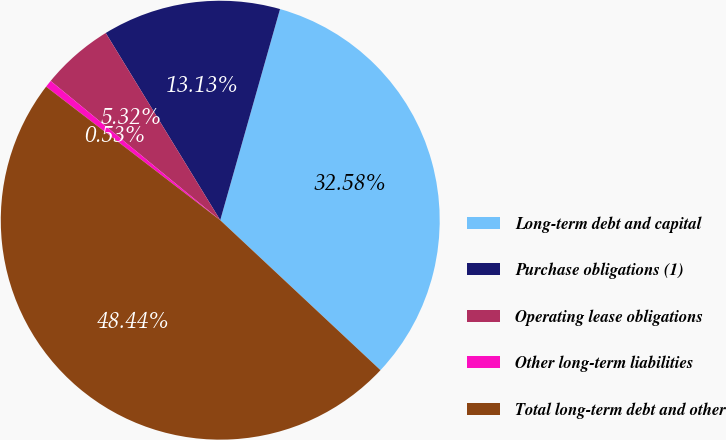Convert chart. <chart><loc_0><loc_0><loc_500><loc_500><pie_chart><fcel>Long-term debt and capital<fcel>Purchase obligations (1)<fcel>Operating lease obligations<fcel>Other long-term liabilities<fcel>Total long-term debt and other<nl><fcel>32.58%<fcel>13.13%<fcel>5.32%<fcel>0.53%<fcel>48.44%<nl></chart> 